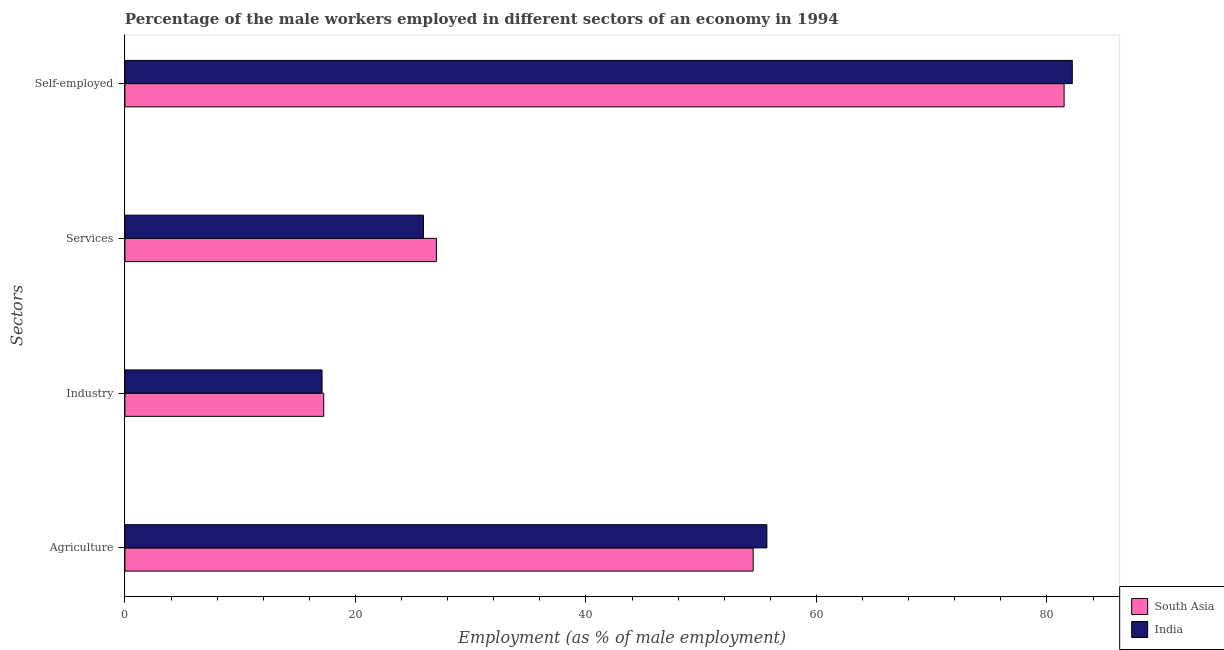How many different coloured bars are there?
Ensure brevity in your answer.  2. How many groups of bars are there?
Offer a very short reply. 4. Are the number of bars per tick equal to the number of legend labels?
Your response must be concise. Yes. Are the number of bars on each tick of the Y-axis equal?
Provide a short and direct response. Yes. How many bars are there on the 2nd tick from the top?
Ensure brevity in your answer.  2. What is the label of the 4th group of bars from the top?
Provide a short and direct response. Agriculture. What is the percentage of male workers in industry in India?
Provide a short and direct response. 17.1. Across all countries, what is the maximum percentage of male workers in services?
Keep it short and to the point. 27.03. Across all countries, what is the minimum percentage of male workers in services?
Your answer should be compact. 25.9. What is the total percentage of male workers in agriculture in the graph?
Offer a terse response. 110.21. What is the difference between the percentage of self employed male workers in South Asia and that in India?
Ensure brevity in your answer.  -0.71. What is the difference between the percentage of self employed male workers in India and the percentage of male workers in agriculture in South Asia?
Your answer should be very brief. 27.69. What is the average percentage of male workers in agriculture per country?
Make the answer very short. 55.1. What is the difference between the percentage of male workers in services and percentage of self employed male workers in South Asia?
Provide a succinct answer. -54.46. In how many countries, is the percentage of male workers in services greater than 4 %?
Give a very brief answer. 2. What is the ratio of the percentage of male workers in services in India to that in South Asia?
Give a very brief answer. 0.96. Is the percentage of male workers in industry in South Asia less than that in India?
Your answer should be compact. No. What is the difference between the highest and the second highest percentage of self employed male workers?
Offer a terse response. 0.71. What is the difference between the highest and the lowest percentage of self employed male workers?
Offer a terse response. 0.71. In how many countries, is the percentage of male workers in industry greater than the average percentage of male workers in industry taken over all countries?
Ensure brevity in your answer.  1. Is the sum of the percentage of male workers in agriculture in South Asia and India greater than the maximum percentage of male workers in industry across all countries?
Give a very brief answer. Yes. What does the 1st bar from the top in Industry represents?
Offer a very short reply. India. Is it the case that in every country, the sum of the percentage of male workers in agriculture and percentage of male workers in industry is greater than the percentage of male workers in services?
Give a very brief answer. Yes. Are all the bars in the graph horizontal?
Provide a succinct answer. Yes. How many countries are there in the graph?
Ensure brevity in your answer.  2. Are the values on the major ticks of X-axis written in scientific E-notation?
Your answer should be compact. No. Does the graph contain any zero values?
Your response must be concise. No. Does the graph contain grids?
Give a very brief answer. No. Where does the legend appear in the graph?
Give a very brief answer. Bottom right. How many legend labels are there?
Your answer should be compact. 2. How are the legend labels stacked?
Keep it short and to the point. Vertical. What is the title of the graph?
Provide a short and direct response. Percentage of the male workers employed in different sectors of an economy in 1994. What is the label or title of the X-axis?
Offer a terse response. Employment (as % of male employment). What is the label or title of the Y-axis?
Offer a terse response. Sectors. What is the Employment (as % of male employment) of South Asia in Agriculture?
Make the answer very short. 54.51. What is the Employment (as % of male employment) of India in Agriculture?
Ensure brevity in your answer.  55.7. What is the Employment (as % of male employment) of South Asia in Industry?
Your answer should be very brief. 17.25. What is the Employment (as % of male employment) in India in Industry?
Give a very brief answer. 17.1. What is the Employment (as % of male employment) of South Asia in Services?
Make the answer very short. 27.03. What is the Employment (as % of male employment) in India in Services?
Your answer should be compact. 25.9. What is the Employment (as % of male employment) of South Asia in Self-employed?
Give a very brief answer. 81.49. What is the Employment (as % of male employment) in India in Self-employed?
Provide a short and direct response. 82.2. Across all Sectors, what is the maximum Employment (as % of male employment) in South Asia?
Provide a short and direct response. 81.49. Across all Sectors, what is the maximum Employment (as % of male employment) of India?
Provide a short and direct response. 82.2. Across all Sectors, what is the minimum Employment (as % of male employment) of South Asia?
Ensure brevity in your answer.  17.25. Across all Sectors, what is the minimum Employment (as % of male employment) in India?
Your response must be concise. 17.1. What is the total Employment (as % of male employment) of South Asia in the graph?
Offer a terse response. 180.27. What is the total Employment (as % of male employment) of India in the graph?
Provide a short and direct response. 180.9. What is the difference between the Employment (as % of male employment) of South Asia in Agriculture and that in Industry?
Keep it short and to the point. 37.26. What is the difference between the Employment (as % of male employment) in India in Agriculture and that in Industry?
Offer a terse response. 38.6. What is the difference between the Employment (as % of male employment) in South Asia in Agriculture and that in Services?
Keep it short and to the point. 27.48. What is the difference between the Employment (as % of male employment) of India in Agriculture and that in Services?
Give a very brief answer. 29.8. What is the difference between the Employment (as % of male employment) in South Asia in Agriculture and that in Self-employed?
Your response must be concise. -26.98. What is the difference between the Employment (as % of male employment) in India in Agriculture and that in Self-employed?
Give a very brief answer. -26.5. What is the difference between the Employment (as % of male employment) of South Asia in Industry and that in Services?
Offer a very short reply. -9.78. What is the difference between the Employment (as % of male employment) in South Asia in Industry and that in Self-employed?
Provide a short and direct response. -64.24. What is the difference between the Employment (as % of male employment) in India in Industry and that in Self-employed?
Offer a terse response. -65.1. What is the difference between the Employment (as % of male employment) in South Asia in Services and that in Self-employed?
Provide a short and direct response. -54.46. What is the difference between the Employment (as % of male employment) in India in Services and that in Self-employed?
Ensure brevity in your answer.  -56.3. What is the difference between the Employment (as % of male employment) in South Asia in Agriculture and the Employment (as % of male employment) in India in Industry?
Your response must be concise. 37.41. What is the difference between the Employment (as % of male employment) of South Asia in Agriculture and the Employment (as % of male employment) of India in Services?
Your answer should be compact. 28.61. What is the difference between the Employment (as % of male employment) of South Asia in Agriculture and the Employment (as % of male employment) of India in Self-employed?
Make the answer very short. -27.69. What is the difference between the Employment (as % of male employment) of South Asia in Industry and the Employment (as % of male employment) of India in Services?
Offer a very short reply. -8.65. What is the difference between the Employment (as % of male employment) of South Asia in Industry and the Employment (as % of male employment) of India in Self-employed?
Your answer should be very brief. -64.95. What is the difference between the Employment (as % of male employment) of South Asia in Services and the Employment (as % of male employment) of India in Self-employed?
Your response must be concise. -55.17. What is the average Employment (as % of male employment) of South Asia per Sectors?
Provide a succinct answer. 45.07. What is the average Employment (as % of male employment) of India per Sectors?
Keep it short and to the point. 45.23. What is the difference between the Employment (as % of male employment) in South Asia and Employment (as % of male employment) in India in Agriculture?
Give a very brief answer. -1.19. What is the difference between the Employment (as % of male employment) in South Asia and Employment (as % of male employment) in India in Industry?
Provide a short and direct response. 0.15. What is the difference between the Employment (as % of male employment) in South Asia and Employment (as % of male employment) in India in Services?
Provide a succinct answer. 1.13. What is the difference between the Employment (as % of male employment) in South Asia and Employment (as % of male employment) in India in Self-employed?
Make the answer very short. -0.71. What is the ratio of the Employment (as % of male employment) in South Asia in Agriculture to that in Industry?
Make the answer very short. 3.16. What is the ratio of the Employment (as % of male employment) of India in Agriculture to that in Industry?
Offer a very short reply. 3.26. What is the ratio of the Employment (as % of male employment) in South Asia in Agriculture to that in Services?
Provide a succinct answer. 2.02. What is the ratio of the Employment (as % of male employment) in India in Agriculture to that in Services?
Make the answer very short. 2.15. What is the ratio of the Employment (as % of male employment) in South Asia in Agriculture to that in Self-employed?
Your answer should be compact. 0.67. What is the ratio of the Employment (as % of male employment) of India in Agriculture to that in Self-employed?
Make the answer very short. 0.68. What is the ratio of the Employment (as % of male employment) of South Asia in Industry to that in Services?
Ensure brevity in your answer.  0.64. What is the ratio of the Employment (as % of male employment) in India in Industry to that in Services?
Give a very brief answer. 0.66. What is the ratio of the Employment (as % of male employment) in South Asia in Industry to that in Self-employed?
Your answer should be very brief. 0.21. What is the ratio of the Employment (as % of male employment) in India in Industry to that in Self-employed?
Provide a succinct answer. 0.21. What is the ratio of the Employment (as % of male employment) in South Asia in Services to that in Self-employed?
Your response must be concise. 0.33. What is the ratio of the Employment (as % of male employment) in India in Services to that in Self-employed?
Give a very brief answer. 0.32. What is the difference between the highest and the second highest Employment (as % of male employment) of South Asia?
Your answer should be very brief. 26.98. What is the difference between the highest and the lowest Employment (as % of male employment) in South Asia?
Offer a terse response. 64.24. What is the difference between the highest and the lowest Employment (as % of male employment) in India?
Offer a very short reply. 65.1. 